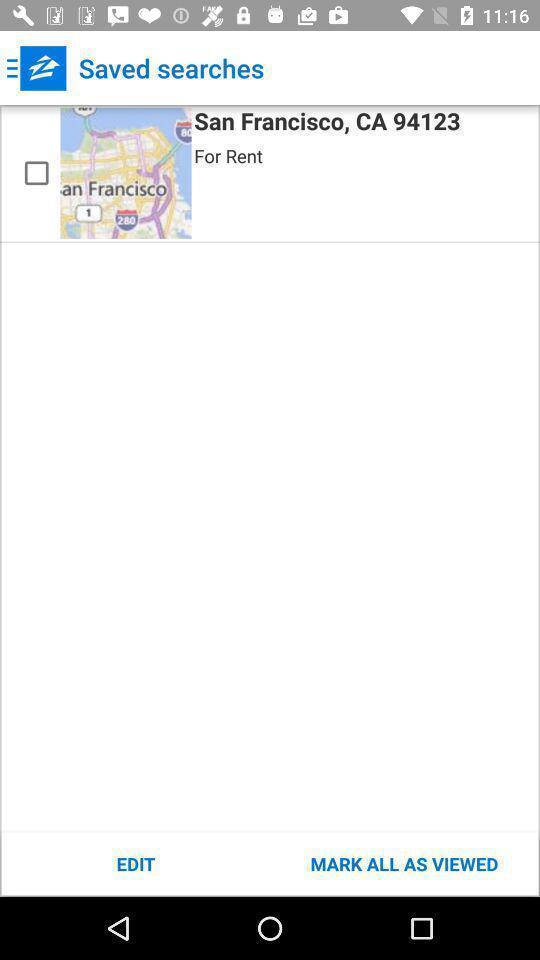What is the overall content of this screenshot? Page of a rental app showing a saved search. 